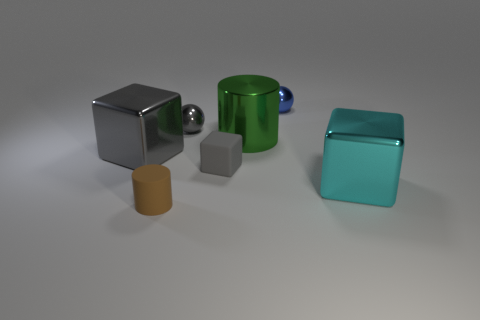Does the gray ball have the same size as the cylinder behind the big cyan cube?
Keep it short and to the point. No. Are there the same number of objects left of the tiny blue ball and tiny brown things on the right side of the gray shiny ball?
Provide a short and direct response. No. The tiny thing that is the same color as the small cube is what shape?
Offer a very short reply. Sphere. What material is the gray thing that is on the right side of the tiny gray ball?
Your response must be concise. Rubber. Do the blue shiny thing and the brown thing have the same size?
Offer a terse response. Yes. Is the number of cyan metal cubes that are right of the gray shiny ball greater than the number of rubber things?
Provide a short and direct response. No. There is a green thing that is the same material as the blue thing; what size is it?
Make the answer very short. Large. Are there any big cubes on the right side of the brown rubber object?
Ensure brevity in your answer.  Yes. Is the shape of the cyan object the same as the tiny blue thing?
Provide a succinct answer. No. What size is the gray metal thing in front of the green shiny cylinder right of the large metallic cube to the left of the brown matte cylinder?
Offer a terse response. Large. 